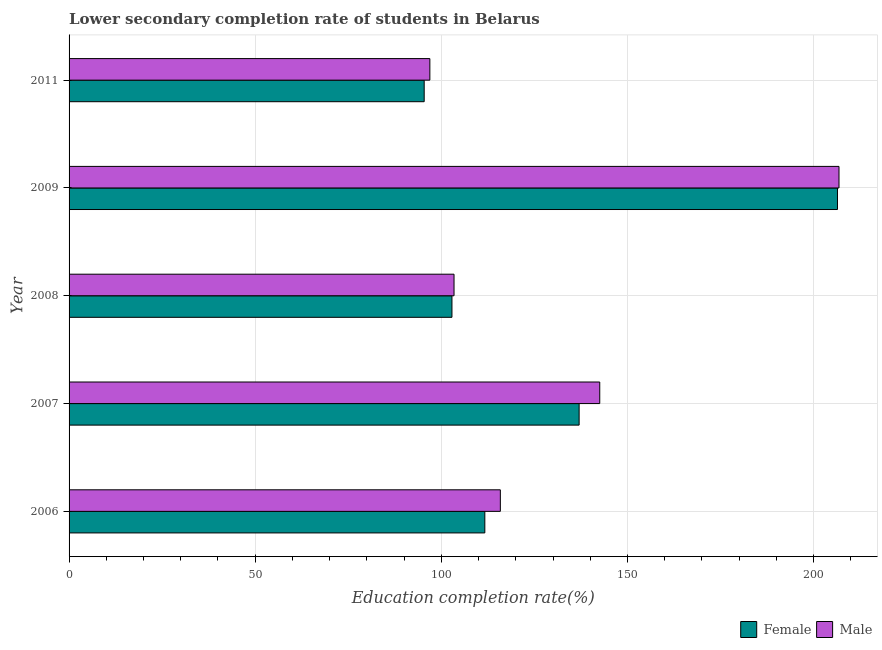How many groups of bars are there?
Your response must be concise. 5. Are the number of bars on each tick of the Y-axis equal?
Your response must be concise. Yes. How many bars are there on the 1st tick from the bottom?
Your answer should be very brief. 2. What is the label of the 2nd group of bars from the top?
Your answer should be very brief. 2009. What is the education completion rate of female students in 2006?
Keep it short and to the point. 111.68. Across all years, what is the maximum education completion rate of male students?
Provide a succinct answer. 206.82. Across all years, what is the minimum education completion rate of male students?
Offer a terse response. 96.92. In which year was the education completion rate of male students minimum?
Provide a short and direct response. 2011. What is the total education completion rate of female students in the graph?
Make the answer very short. 653.36. What is the difference between the education completion rate of male students in 2006 and that in 2011?
Your response must be concise. 18.93. What is the difference between the education completion rate of female students in 2009 and the education completion rate of male students in 2011?
Keep it short and to the point. 109.5. What is the average education completion rate of female students per year?
Give a very brief answer. 130.67. In the year 2007, what is the difference between the education completion rate of male students and education completion rate of female students?
Give a very brief answer. 5.54. What is the ratio of the education completion rate of female students in 2008 to that in 2009?
Give a very brief answer. 0.5. Is the education completion rate of male students in 2006 less than that in 2008?
Give a very brief answer. No. Is the difference between the education completion rate of female students in 2008 and 2011 greater than the difference between the education completion rate of male students in 2008 and 2011?
Offer a terse response. Yes. What is the difference between the highest and the second highest education completion rate of male students?
Your answer should be compact. 64.27. What is the difference between the highest and the lowest education completion rate of male students?
Provide a succinct answer. 109.91. Is the sum of the education completion rate of female students in 2007 and 2009 greater than the maximum education completion rate of male students across all years?
Your answer should be compact. Yes. Does the graph contain grids?
Provide a succinct answer. Yes. How many legend labels are there?
Offer a very short reply. 2. How are the legend labels stacked?
Provide a succinct answer. Horizontal. What is the title of the graph?
Your response must be concise. Lower secondary completion rate of students in Belarus. What is the label or title of the X-axis?
Your answer should be compact. Education completion rate(%). What is the label or title of the Y-axis?
Offer a terse response. Year. What is the Education completion rate(%) of Female in 2006?
Provide a succinct answer. 111.68. What is the Education completion rate(%) of Male in 2006?
Ensure brevity in your answer.  115.85. What is the Education completion rate(%) in Female in 2007?
Offer a terse response. 137.01. What is the Education completion rate(%) of Male in 2007?
Your answer should be compact. 142.56. What is the Education completion rate(%) in Female in 2008?
Keep it short and to the point. 102.85. What is the Education completion rate(%) of Male in 2008?
Offer a terse response. 103.41. What is the Education completion rate(%) of Female in 2009?
Ensure brevity in your answer.  206.42. What is the Education completion rate(%) in Male in 2009?
Your answer should be compact. 206.82. What is the Education completion rate(%) of Female in 2011?
Offer a terse response. 95.4. What is the Education completion rate(%) in Male in 2011?
Your answer should be compact. 96.92. Across all years, what is the maximum Education completion rate(%) of Female?
Your response must be concise. 206.42. Across all years, what is the maximum Education completion rate(%) of Male?
Give a very brief answer. 206.82. Across all years, what is the minimum Education completion rate(%) in Female?
Offer a very short reply. 95.4. Across all years, what is the minimum Education completion rate(%) of Male?
Ensure brevity in your answer.  96.92. What is the total Education completion rate(%) in Female in the graph?
Your response must be concise. 653.36. What is the total Education completion rate(%) in Male in the graph?
Offer a terse response. 665.56. What is the difference between the Education completion rate(%) of Female in 2006 and that in 2007?
Provide a succinct answer. -25.33. What is the difference between the Education completion rate(%) in Male in 2006 and that in 2007?
Your answer should be very brief. -26.7. What is the difference between the Education completion rate(%) in Female in 2006 and that in 2008?
Provide a succinct answer. 8.83. What is the difference between the Education completion rate(%) of Male in 2006 and that in 2008?
Keep it short and to the point. 12.44. What is the difference between the Education completion rate(%) in Female in 2006 and that in 2009?
Make the answer very short. -94.73. What is the difference between the Education completion rate(%) of Male in 2006 and that in 2009?
Your answer should be compact. -90.97. What is the difference between the Education completion rate(%) in Female in 2006 and that in 2011?
Provide a succinct answer. 16.29. What is the difference between the Education completion rate(%) in Male in 2006 and that in 2011?
Give a very brief answer. 18.93. What is the difference between the Education completion rate(%) of Female in 2007 and that in 2008?
Offer a terse response. 34.16. What is the difference between the Education completion rate(%) of Male in 2007 and that in 2008?
Your answer should be compact. 39.14. What is the difference between the Education completion rate(%) in Female in 2007 and that in 2009?
Offer a terse response. -69.4. What is the difference between the Education completion rate(%) in Male in 2007 and that in 2009?
Keep it short and to the point. -64.27. What is the difference between the Education completion rate(%) in Female in 2007 and that in 2011?
Keep it short and to the point. 41.62. What is the difference between the Education completion rate(%) of Male in 2007 and that in 2011?
Your answer should be compact. 45.64. What is the difference between the Education completion rate(%) in Female in 2008 and that in 2009?
Provide a short and direct response. -103.56. What is the difference between the Education completion rate(%) of Male in 2008 and that in 2009?
Keep it short and to the point. -103.41. What is the difference between the Education completion rate(%) in Female in 2008 and that in 2011?
Your answer should be very brief. 7.46. What is the difference between the Education completion rate(%) of Male in 2008 and that in 2011?
Give a very brief answer. 6.49. What is the difference between the Education completion rate(%) in Female in 2009 and that in 2011?
Your answer should be very brief. 111.02. What is the difference between the Education completion rate(%) in Male in 2009 and that in 2011?
Provide a succinct answer. 109.91. What is the difference between the Education completion rate(%) in Female in 2006 and the Education completion rate(%) in Male in 2007?
Your answer should be compact. -30.87. What is the difference between the Education completion rate(%) in Female in 2006 and the Education completion rate(%) in Male in 2008?
Offer a very short reply. 8.27. What is the difference between the Education completion rate(%) of Female in 2006 and the Education completion rate(%) of Male in 2009?
Offer a very short reply. -95.14. What is the difference between the Education completion rate(%) of Female in 2006 and the Education completion rate(%) of Male in 2011?
Offer a terse response. 14.77. What is the difference between the Education completion rate(%) in Female in 2007 and the Education completion rate(%) in Male in 2008?
Offer a terse response. 33.6. What is the difference between the Education completion rate(%) of Female in 2007 and the Education completion rate(%) of Male in 2009?
Provide a short and direct response. -69.81. What is the difference between the Education completion rate(%) of Female in 2007 and the Education completion rate(%) of Male in 2011?
Provide a short and direct response. 40.1. What is the difference between the Education completion rate(%) of Female in 2008 and the Education completion rate(%) of Male in 2009?
Your response must be concise. -103.97. What is the difference between the Education completion rate(%) in Female in 2008 and the Education completion rate(%) in Male in 2011?
Your answer should be compact. 5.93. What is the difference between the Education completion rate(%) in Female in 2009 and the Education completion rate(%) in Male in 2011?
Make the answer very short. 109.5. What is the average Education completion rate(%) in Female per year?
Make the answer very short. 130.67. What is the average Education completion rate(%) in Male per year?
Keep it short and to the point. 133.11. In the year 2006, what is the difference between the Education completion rate(%) in Female and Education completion rate(%) in Male?
Provide a succinct answer. -4.17. In the year 2007, what is the difference between the Education completion rate(%) in Female and Education completion rate(%) in Male?
Keep it short and to the point. -5.54. In the year 2008, what is the difference between the Education completion rate(%) of Female and Education completion rate(%) of Male?
Offer a terse response. -0.56. In the year 2009, what is the difference between the Education completion rate(%) of Female and Education completion rate(%) of Male?
Offer a very short reply. -0.41. In the year 2011, what is the difference between the Education completion rate(%) of Female and Education completion rate(%) of Male?
Make the answer very short. -1.52. What is the ratio of the Education completion rate(%) of Female in 2006 to that in 2007?
Ensure brevity in your answer.  0.82. What is the ratio of the Education completion rate(%) of Male in 2006 to that in 2007?
Provide a short and direct response. 0.81. What is the ratio of the Education completion rate(%) in Female in 2006 to that in 2008?
Your response must be concise. 1.09. What is the ratio of the Education completion rate(%) of Male in 2006 to that in 2008?
Your answer should be compact. 1.12. What is the ratio of the Education completion rate(%) in Female in 2006 to that in 2009?
Your answer should be compact. 0.54. What is the ratio of the Education completion rate(%) of Male in 2006 to that in 2009?
Your answer should be very brief. 0.56. What is the ratio of the Education completion rate(%) in Female in 2006 to that in 2011?
Offer a terse response. 1.17. What is the ratio of the Education completion rate(%) of Male in 2006 to that in 2011?
Ensure brevity in your answer.  1.2. What is the ratio of the Education completion rate(%) of Female in 2007 to that in 2008?
Provide a succinct answer. 1.33. What is the ratio of the Education completion rate(%) in Male in 2007 to that in 2008?
Provide a succinct answer. 1.38. What is the ratio of the Education completion rate(%) of Female in 2007 to that in 2009?
Your answer should be compact. 0.66. What is the ratio of the Education completion rate(%) in Male in 2007 to that in 2009?
Offer a terse response. 0.69. What is the ratio of the Education completion rate(%) of Female in 2007 to that in 2011?
Provide a succinct answer. 1.44. What is the ratio of the Education completion rate(%) in Male in 2007 to that in 2011?
Offer a terse response. 1.47. What is the ratio of the Education completion rate(%) in Female in 2008 to that in 2009?
Provide a short and direct response. 0.5. What is the ratio of the Education completion rate(%) of Male in 2008 to that in 2009?
Your response must be concise. 0.5. What is the ratio of the Education completion rate(%) in Female in 2008 to that in 2011?
Your answer should be very brief. 1.08. What is the ratio of the Education completion rate(%) of Male in 2008 to that in 2011?
Your response must be concise. 1.07. What is the ratio of the Education completion rate(%) in Female in 2009 to that in 2011?
Give a very brief answer. 2.16. What is the ratio of the Education completion rate(%) of Male in 2009 to that in 2011?
Ensure brevity in your answer.  2.13. What is the difference between the highest and the second highest Education completion rate(%) in Female?
Make the answer very short. 69.4. What is the difference between the highest and the second highest Education completion rate(%) of Male?
Your response must be concise. 64.27. What is the difference between the highest and the lowest Education completion rate(%) in Female?
Keep it short and to the point. 111.02. What is the difference between the highest and the lowest Education completion rate(%) in Male?
Your answer should be compact. 109.91. 